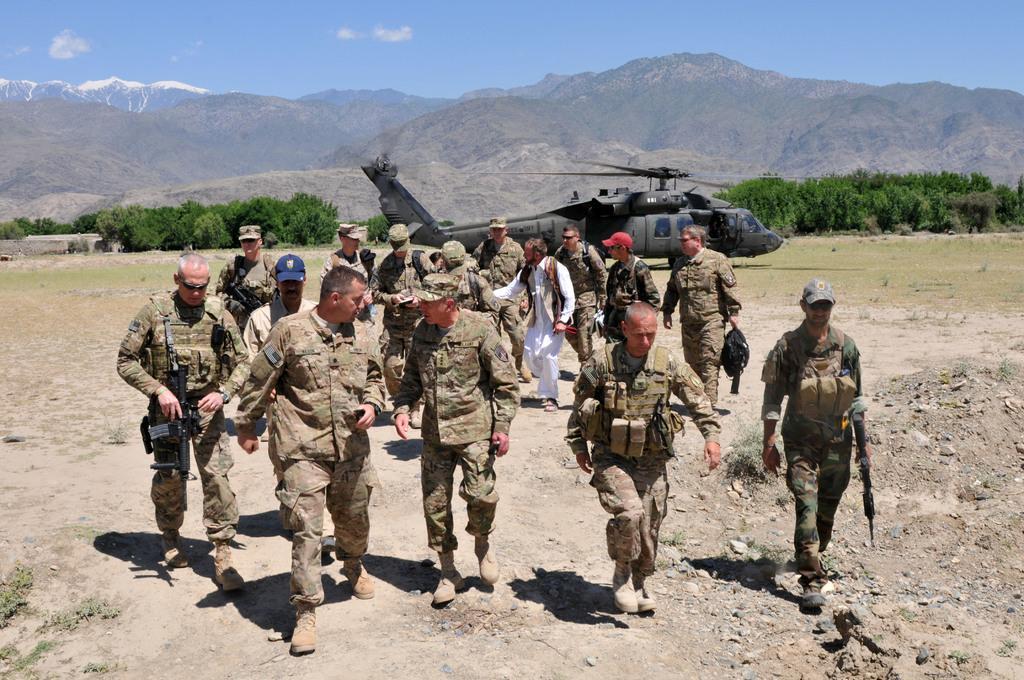Please provide a concise description of this image. In the picture I can see people wearing army uniforms and shoes are walking on the ground. In the background, I can see a helicopter, trees, mountains and the blue sky with clouds. 